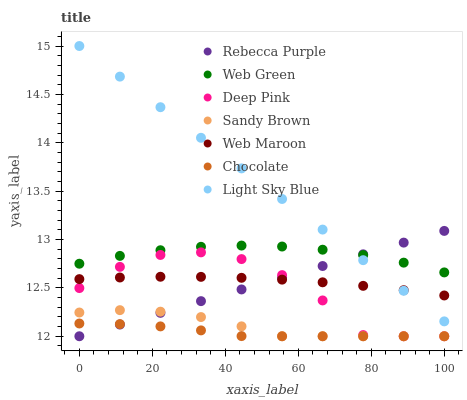Does Chocolate have the minimum area under the curve?
Answer yes or no. Yes. Does Light Sky Blue have the maximum area under the curve?
Answer yes or no. Yes. Does Web Maroon have the minimum area under the curve?
Answer yes or no. No. Does Web Maroon have the maximum area under the curve?
Answer yes or no. No. Is Rebecca Purple the smoothest?
Answer yes or no. Yes. Is Deep Pink the roughest?
Answer yes or no. Yes. Is Web Maroon the smoothest?
Answer yes or no. No. Is Web Maroon the roughest?
Answer yes or no. No. Does Deep Pink have the lowest value?
Answer yes or no. Yes. Does Web Maroon have the lowest value?
Answer yes or no. No. Does Light Sky Blue have the highest value?
Answer yes or no. Yes. Does Web Maroon have the highest value?
Answer yes or no. No. Is Sandy Brown less than Web Maroon?
Answer yes or no. Yes. Is Web Green greater than Sandy Brown?
Answer yes or no. Yes. Does Chocolate intersect Rebecca Purple?
Answer yes or no. Yes. Is Chocolate less than Rebecca Purple?
Answer yes or no. No. Is Chocolate greater than Rebecca Purple?
Answer yes or no. No. Does Sandy Brown intersect Web Maroon?
Answer yes or no. No. 